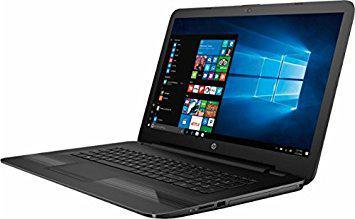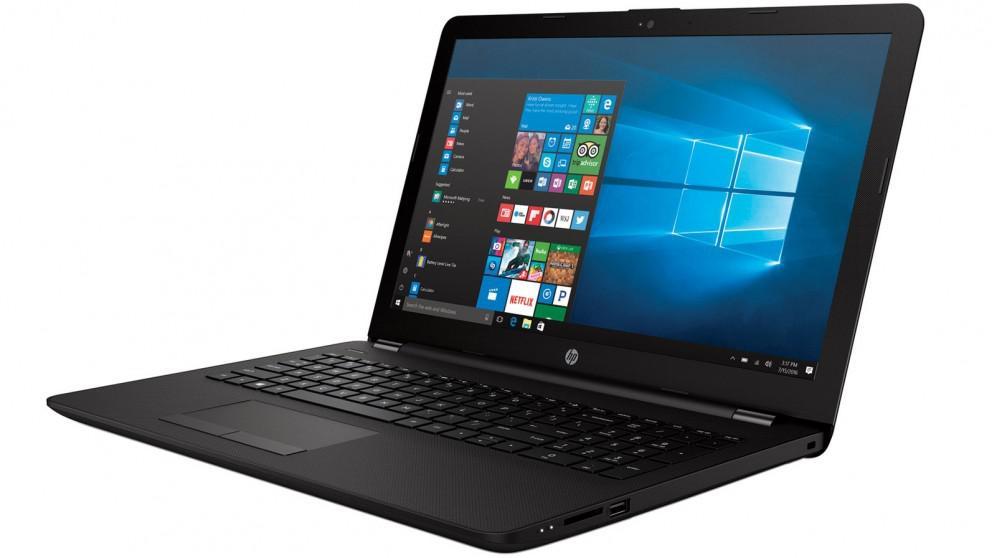The first image is the image on the left, the second image is the image on the right. Assess this claim about the two images: "The laptops are facing towards the left side of the image.". Correct or not? Answer yes or no. Yes. 